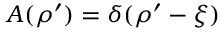Convert formula to latex. <formula><loc_0><loc_0><loc_500><loc_500>A ( \rho ^ { \prime } ) = \delta ( \rho ^ { \prime } - \xi )</formula> 